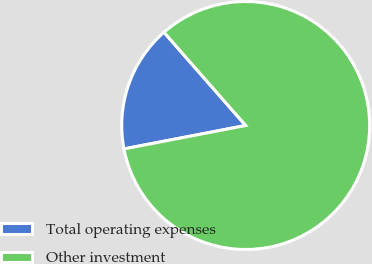Convert chart to OTSL. <chart><loc_0><loc_0><loc_500><loc_500><pie_chart><fcel>Total operating expenses<fcel>Other investment<nl><fcel>16.57%<fcel>83.43%<nl></chart> 